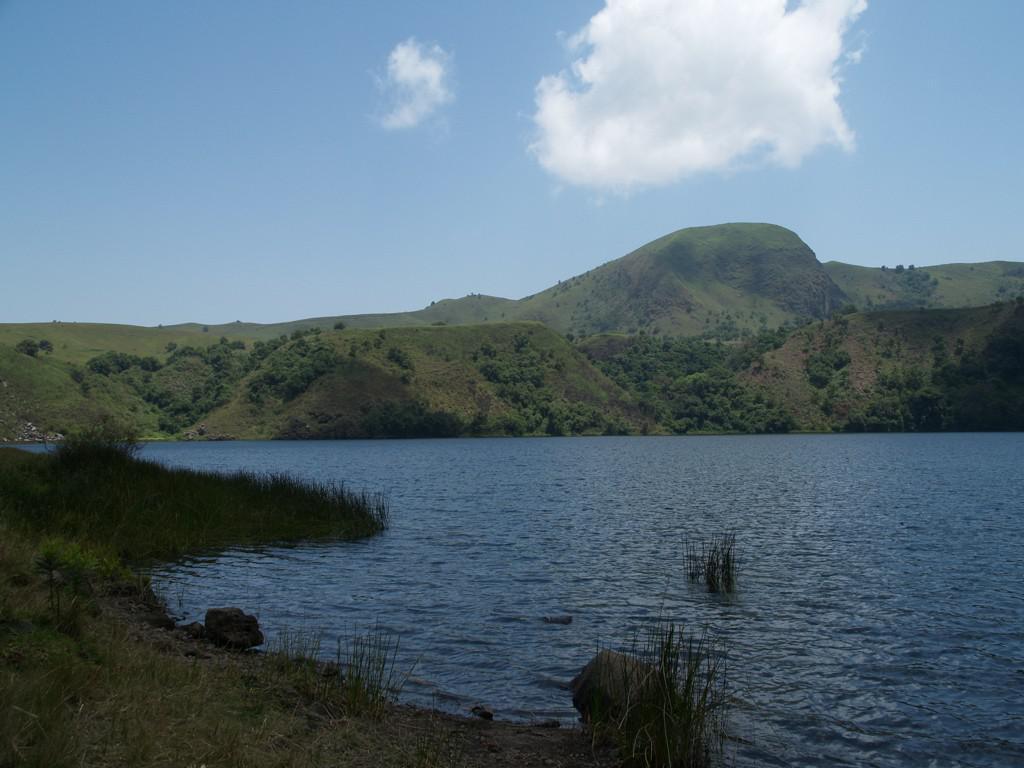In one or two sentences, can you explain what this image depicts? In this image there is water. At the bottom there is grass. In the background there are hills and sky. 